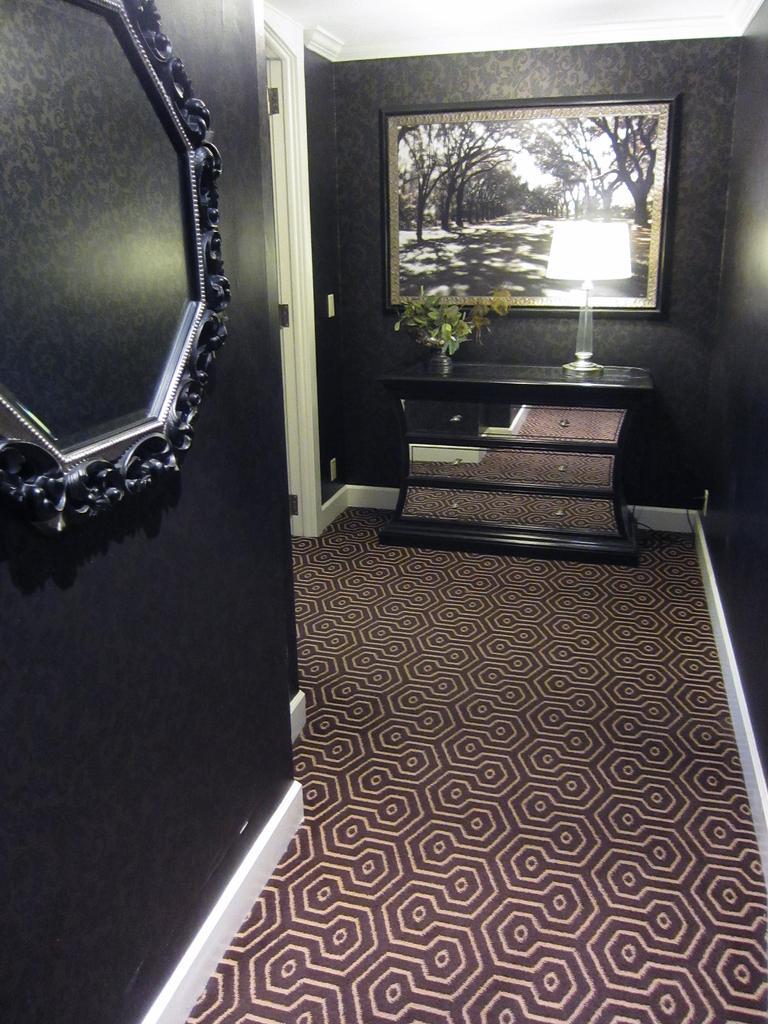Could you give a brief overview of what you see in this image? We have a carpet on the floor and to the left side we have black wall with a photo frame and also we have door to the left side, also we have a photo frame, a lamp and a small plant into the right we have wall 